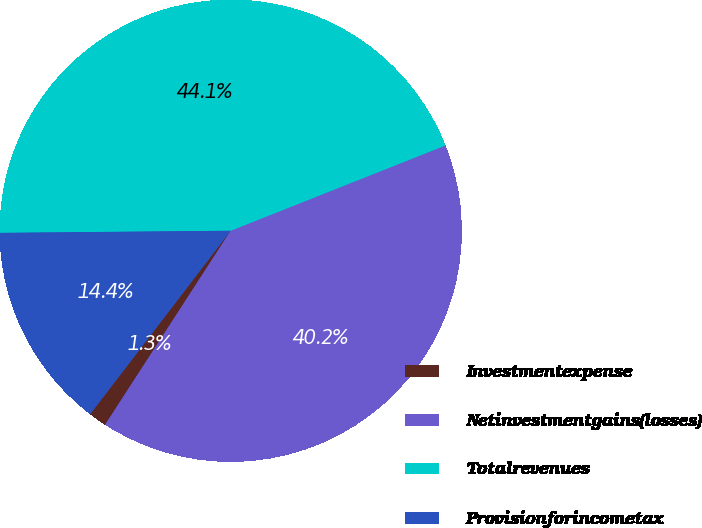Convert chart. <chart><loc_0><loc_0><loc_500><loc_500><pie_chart><fcel>Investmentexpense<fcel>Netinvestmentgains(losses)<fcel>Totalrevenues<fcel>Provisionforincometax<nl><fcel>1.26%<fcel>40.16%<fcel>44.13%<fcel>14.45%<nl></chart> 